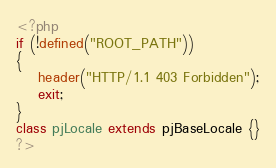<code> <loc_0><loc_0><loc_500><loc_500><_PHP_><?php
if (!defined("ROOT_PATH"))
{
	header("HTTP/1.1 403 Forbidden");
	exit;
}
class pjLocale extends pjBaseLocale {}
?></code> 